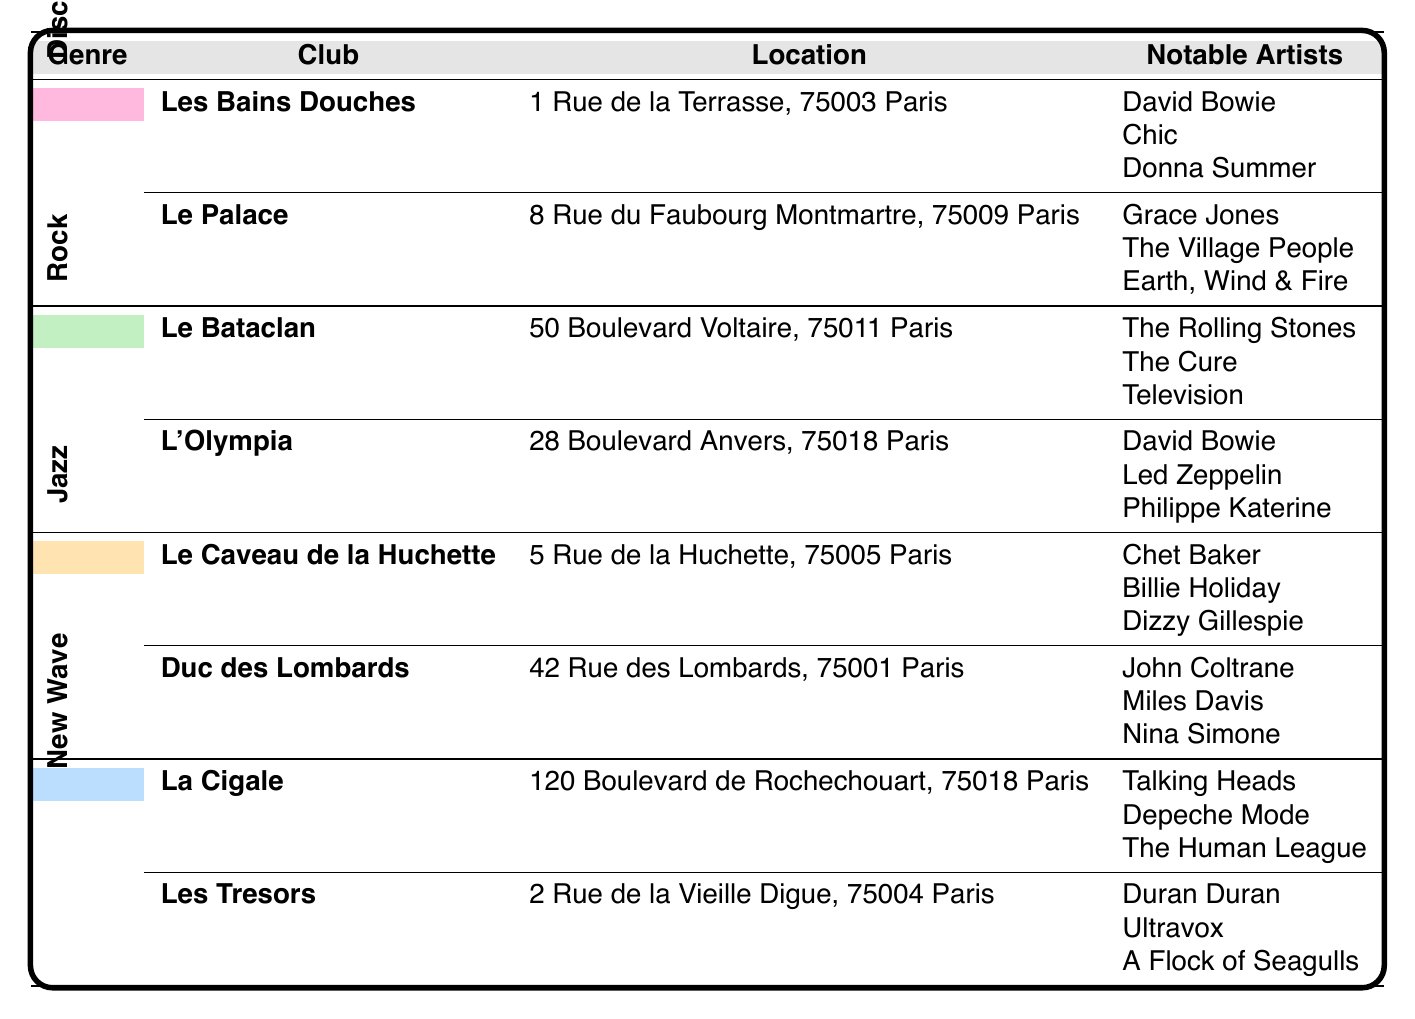What are the notable artists associated with Le Bataclan? According to the table, Le Bataclan features notable artists such as The Rolling Stones, The Cure, and Television.
Answer: The Rolling Stones, The Cure, Television Which club is located at 1 Rue de la Terrasse, 75003 Paris? The table lists Les Bains Douches as the club located at 1 Rue de la Terrasse, 75003 Paris.
Answer: Les Bains Douches How many clubs feature Jazz music in the table? The table shows two clubs associated with Jazz: Le Caveau de la Huchette and Duc des Lombards. Therefore, there are 2 clubs featuring Jazz.
Answer: 2 Is David Bowie a notable artist in more than one club? By examining the table, David Bowie is listed as a notable artist in both Les Bains Douches and L'Olympia, confirming he is associated with more than one club.
Answer: Yes Which music genre has the club named L'Olympia? The table indicates that L'Olympia is associated with the Rock genre.
Answer: Rock What is the difference in the number of notable artists between Disco and New Wave genres? Disco has 6 notable artists (3 from each of its 2 clubs) and New Wave also has 6 notable artists (3 from each of its 2 clubs). Therefore, the difference is 0, as both genres have the same number.
Answer: 0 Which notable artist appears in both Disco and Rock categories? Upon reviewing the notable artists in Disco and Rock, David Bowie appears in both categories.
Answer: David Bowie List the locations of clubs featuring New Wave music. The clubs associated with New Wave music are La Cigale, located at 120 Boulevard de Rochechouart, 75018 Paris, and Les Tresors, at 2 Rue de la Vieille Digue, 75004 Paris.
Answer: 120 Boulevard de Rochechouart, 75018 Paris; 2 Rue de la Vieille Digue, 75004 Paris How many notable artists are listed for the club Duc des Lombards? The table specifies that Duc des Lombards has 3 notable artists: John Coltrane, Miles Davis, and Nina Simone.
Answer: 3 